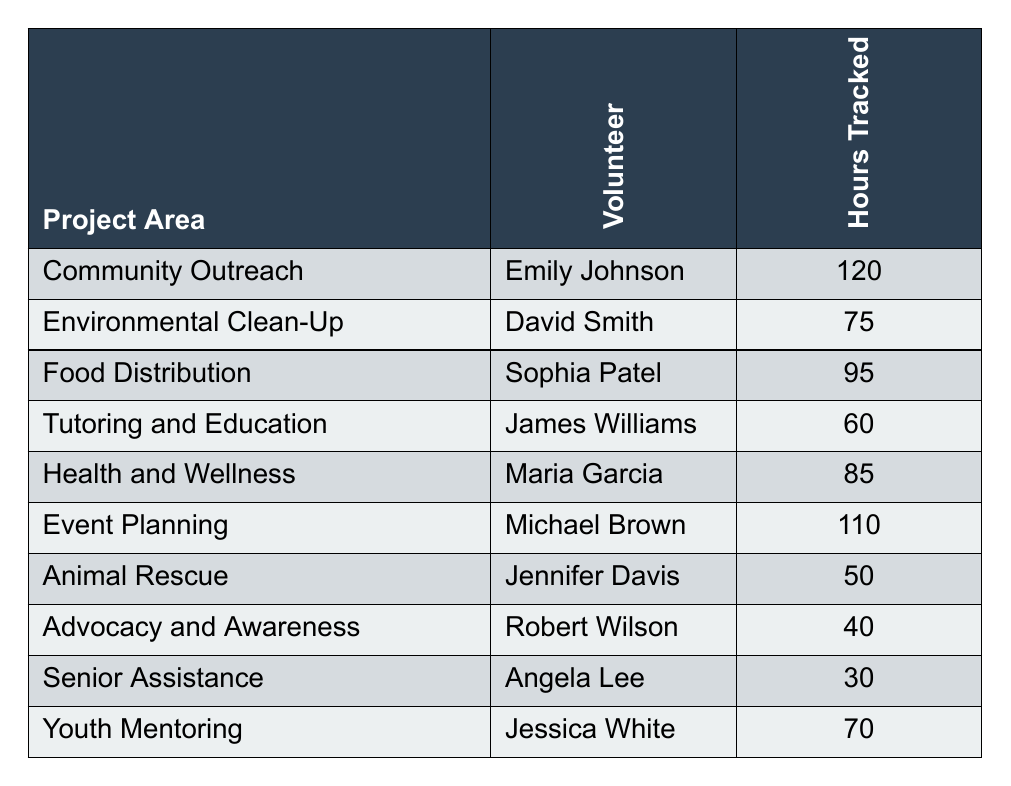What is the total number of volunteer hours tracked across all project areas? To find the total hours, we sum the hours tracked for each volunteer: 120 + 75 + 95 + 60 + 85 + 110 + 50 + 40 + 30 + 70 = 795.
Answer: 795 Who contributed the most hours, and how many hours did they contribute? Emily Johnson contributed the most hours in the Community Outreach project area with 120 hours tracked.
Answer: Emily Johnson, 120 Is there a project area where a volunteer contributed fewer than 40 hours? Yes, the Advocacy and Awareness project area has Robert Wilson who contributed only 40 hours, which meets the condition of being fewer than 40 hours.
Answer: Yes What is the average number of hours tracked by volunteers in the table? There are 10 volunteers, and the total hours tracked is 795. Therefore, the average is 795/10 = 79.5.
Answer: 79.5 How many project areas had volunteers contributing 70 hours or more? The volunteers contributing 70 hours or more are Emily Johnson, Michael Brown, Sophia Patel, and Maria Garcia. Counting these gives us 4 project areas.
Answer: 4 Did any volunteer contribute exactly 60 hours? Yes, James Williams contributed exactly 60 hours in the Tutoring and Education project area.
Answer: Yes Which project area had the least volunteer hours tracked and what was that amount? The project area with the least volunteer hours tracked is Senior Assistance where Angela Lee contributed 30 hours.
Answer: Senior Assistance, 30 What is the difference in hours tracked between the project areas of Community Outreach and Advocacy and Awareness? Community Outreach has 120 hours tracked and Advocacy and Awareness has 40 hours. The difference is 120 - 40 = 80 hours.
Answer: 80 Which volunteer's hours tracked is closest to the median of the hours tracked? First, we list the hours in order: 30, 40, 50, 60, 70, 75, 85, 95, 110, 120. The median is the average of the 5th and 6th values, which is (70 + 75)/2 = 72.5. The volunteer with hours closest to this is Jessica White with 70 hours.
Answer: Jessica White, 70 